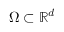<formula> <loc_0><loc_0><loc_500><loc_500>\Omega \subset \mathbb { R } ^ { d }</formula> 